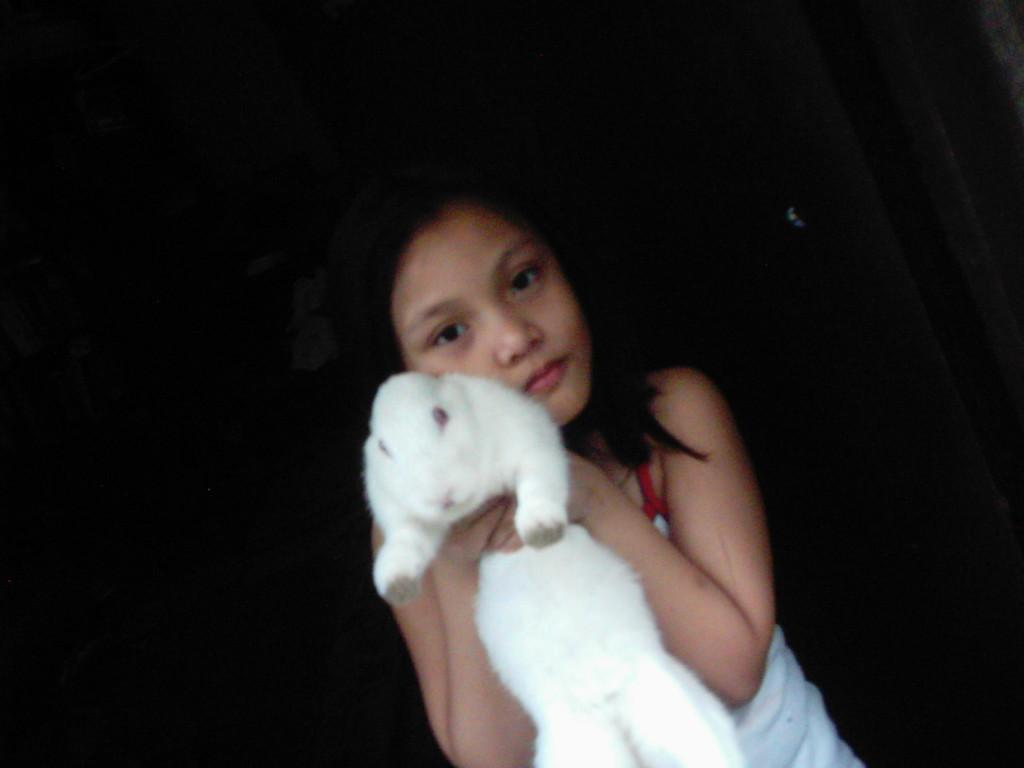Who is the main subject in the image? There is a girl in the image. What is the girl holding in the image? The girl is holding a white rabbit. What is the color of the background in the image? The background of the image is black. What advice is the girl giving to the passengers at the airport in the image? There is no airport or passengers present in the image; it features a girl holding a white rabbit with a black background. 